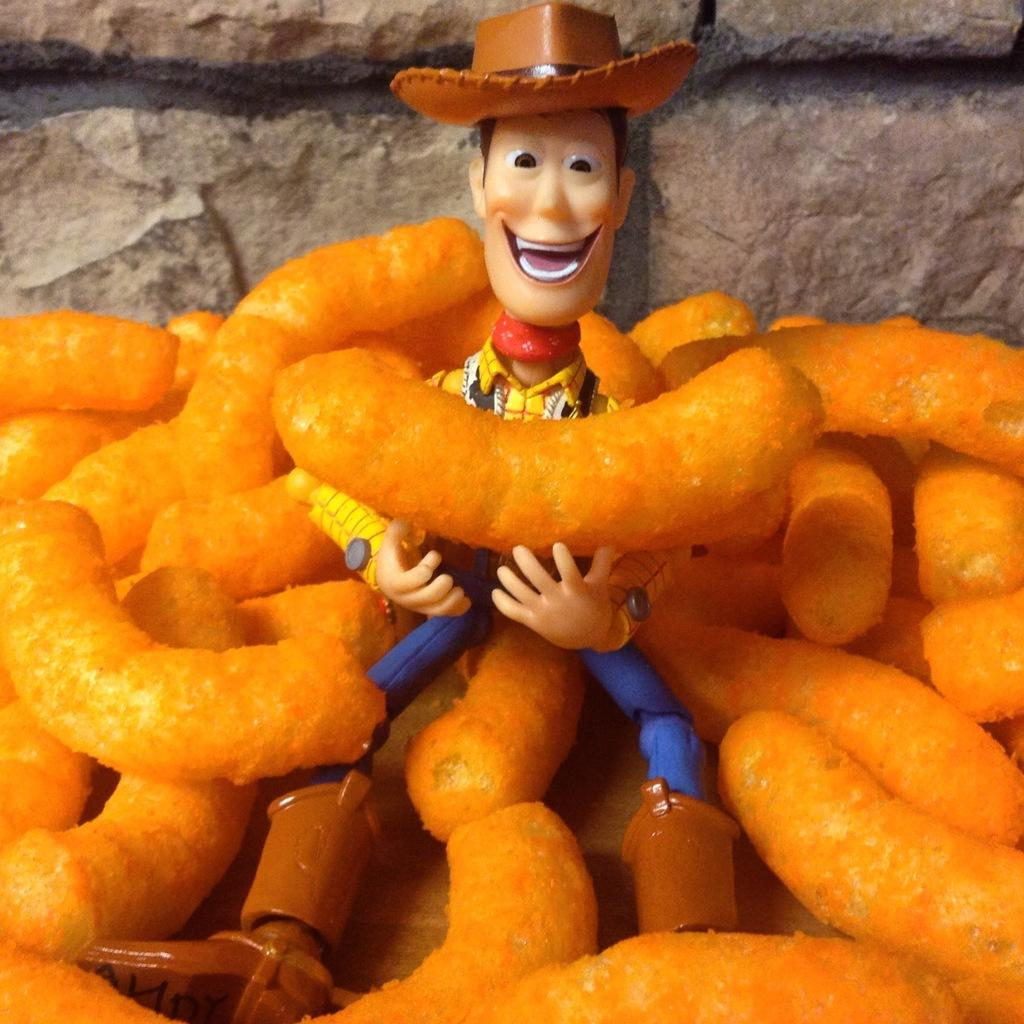What type of object can be seen in the image? There is a toy in the image. What else is present in the image besides the toy? There is a food item in the image. On what object are the toy and food item placed? The toy and food item are placed on an object. What can be seen in the background of the image? There is a wall in the background of the image. What type of ticket is required to enter the nation depicted in the image? There is no nation depicted in the image, and therefore no ticket is required to enter it. What type of breakfast is being prepared in the image? There is no indication of breakfast preparation in the image. 